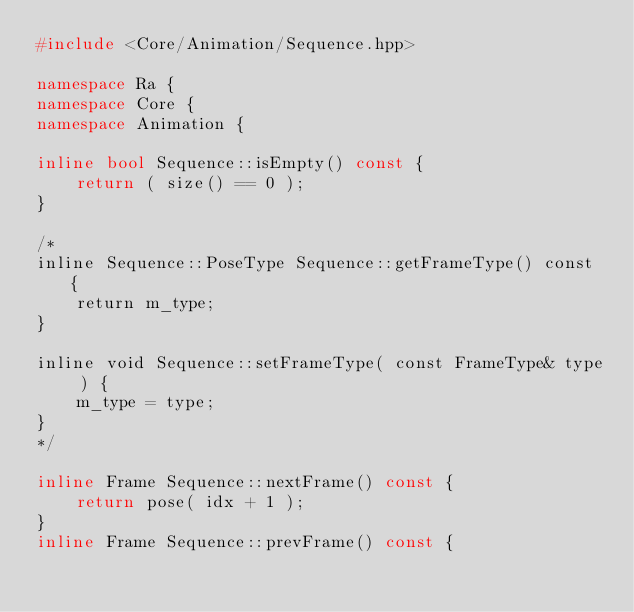<code> <loc_0><loc_0><loc_500><loc_500><_C++_>#include <Core/Animation/Sequence.hpp>

namespace Ra {
namespace Core {
namespace Animation {

inline bool Sequence::isEmpty() const {
    return ( size() == 0 );
}

/*
inline Sequence::PoseType Sequence::getFrameType() const {
    return m_type;
}

inline void Sequence::setFrameType( const FrameType& type ) {
    m_type = type;
}
*/

inline Frame Sequence::nextFrame() const {
    return pose( idx + 1 );
}
inline Frame Sequence::prevFrame() const {</code> 